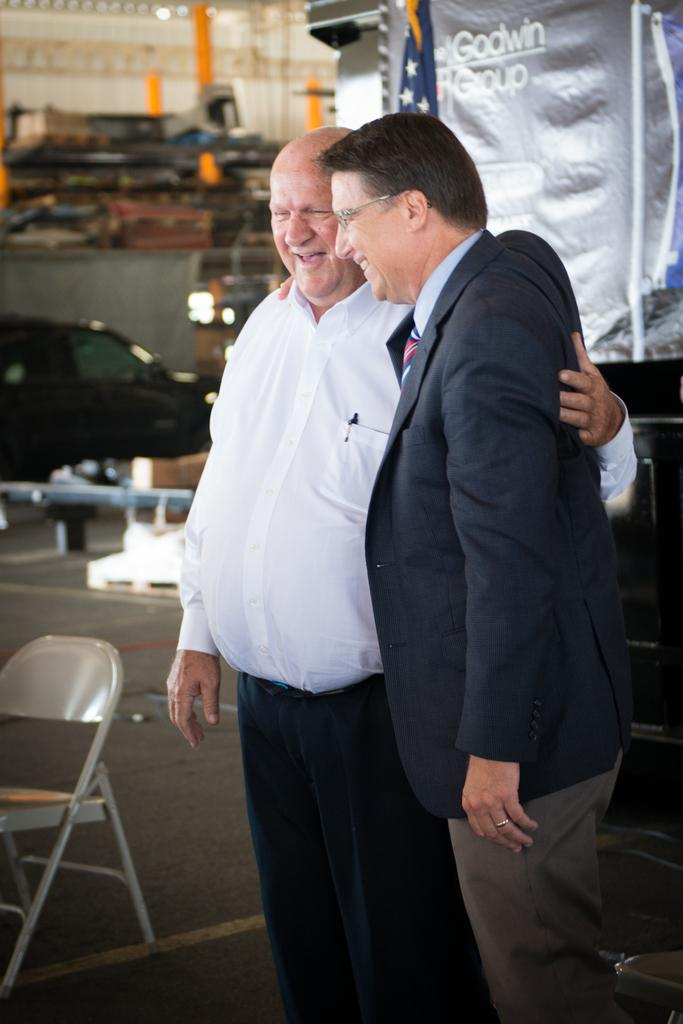How many people are in the image? There are two persons standing in the image. Where are the persons standing? The persons are standing on the floor. What can be seen in the background of the image? There is a chair, a car, and banners in the background of the image. What type of dinner is being served on the faucet in the image? There is no faucet or dinner present in the image. 